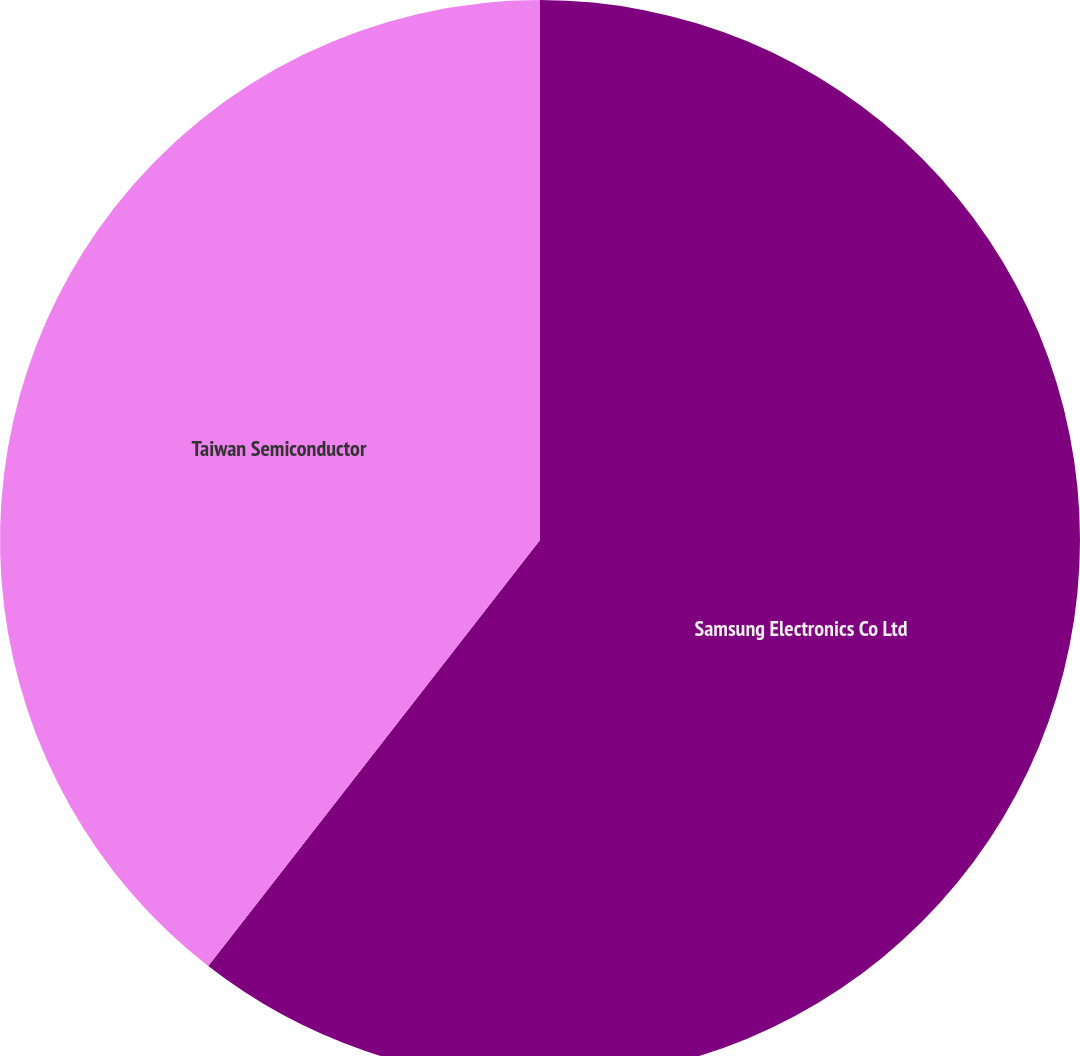Convert chart to OTSL. <chart><loc_0><loc_0><loc_500><loc_500><pie_chart><fcel>Samsung Electronics Co Ltd<fcel>Taiwan Semiconductor<nl><fcel>60.53%<fcel>39.47%<nl></chart> 